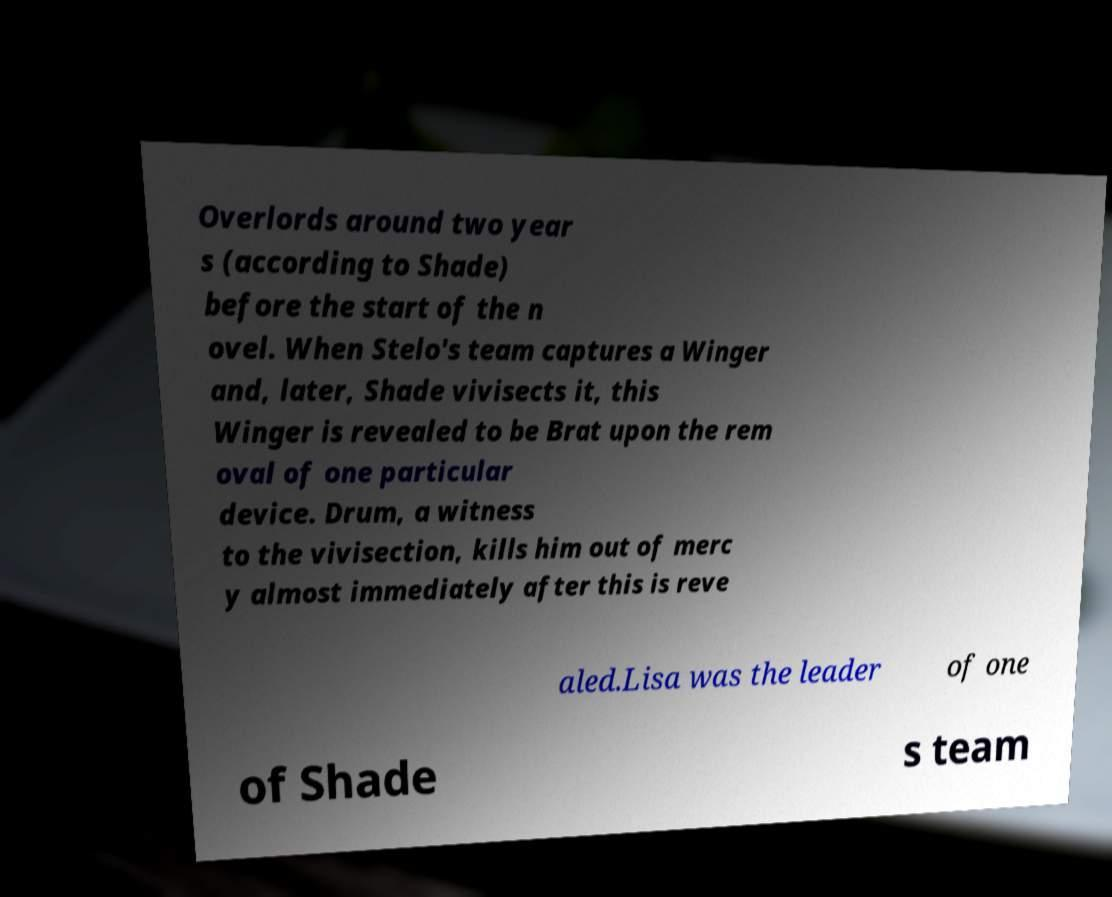For documentation purposes, I need the text within this image transcribed. Could you provide that? Overlords around two year s (according to Shade) before the start of the n ovel. When Stelo's team captures a Winger and, later, Shade vivisects it, this Winger is revealed to be Brat upon the rem oval of one particular device. Drum, a witness to the vivisection, kills him out of merc y almost immediately after this is reve aled.Lisa was the leader of one of Shade s team 